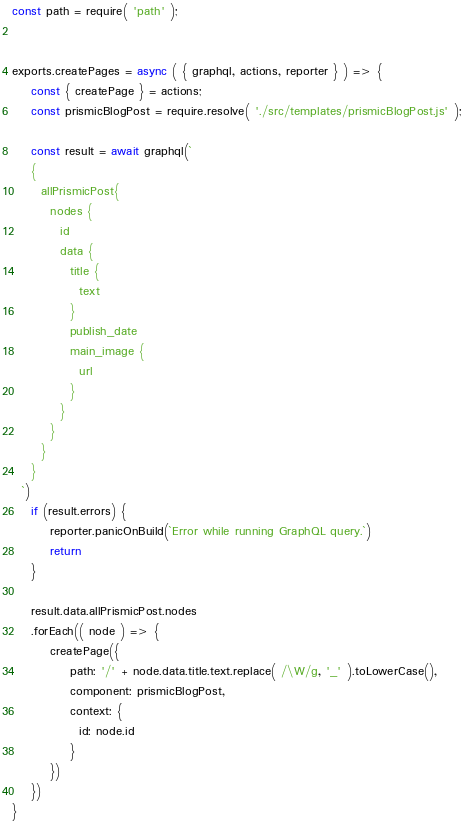<code> <loc_0><loc_0><loc_500><loc_500><_JavaScript_>const path = require( 'path' );


exports.createPages = async ( { graphql, actions, reporter } ) => {
    const { createPage } = actions; 
    const prismicBlogPost = require.resolve( './src/templates/prismicBlogPost.js' ); 

    const result = await graphql(`
    {
      allPrismicPost{
        nodes {
          id
          data {
            title {
              text
            }
            publish_date
            main_image {
              url
            }
          }
        }
      }
    }
  `)
    if (result.errors) {
        reporter.panicOnBuild(`Error while running GraphQL query.`)
        return
    }

    result.data.allPrismicPost.nodes
    .forEach(( node ) => {
        createPage({
            path: '/' + node.data.title.text.replace( /\W/g, '_' ).toLowerCase(),
            component: prismicBlogPost,
            context: {
              id: node.id
            }
        })
    })
}</code> 